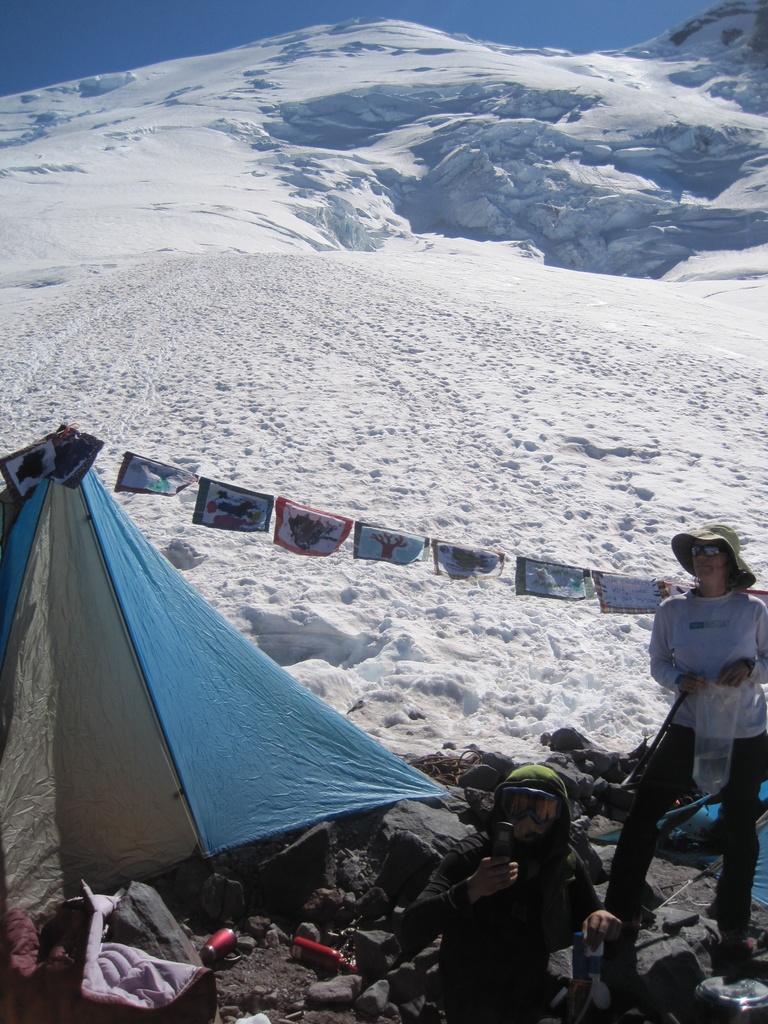Can you describe this image briefly? In the center of the image we can see two persons are in different costumes and they are holding some objects. Among them, we can see one person is wearing a hat and the other person is wearing some object. And we can see a tent, rocks, bottles and a few other objects. In the background, we can see the sky, hills and snow. 